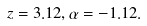Convert formula to latex. <formula><loc_0><loc_0><loc_500><loc_500>z = 3 . 1 2 , \alpha = - 1 . 1 2 .</formula> 